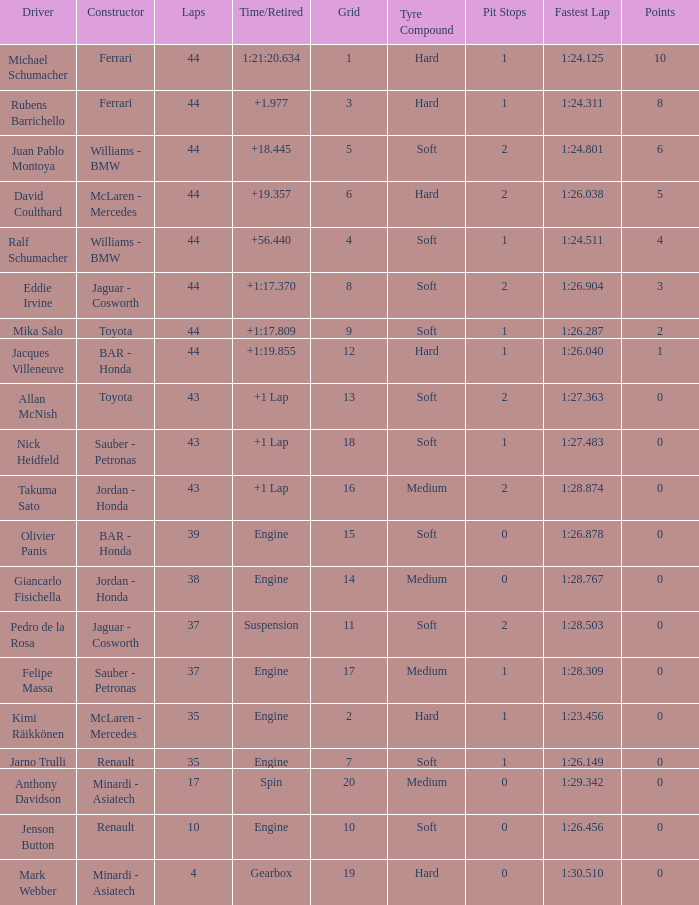What was the fewest laps for somone who finished +18.445? 44.0. 